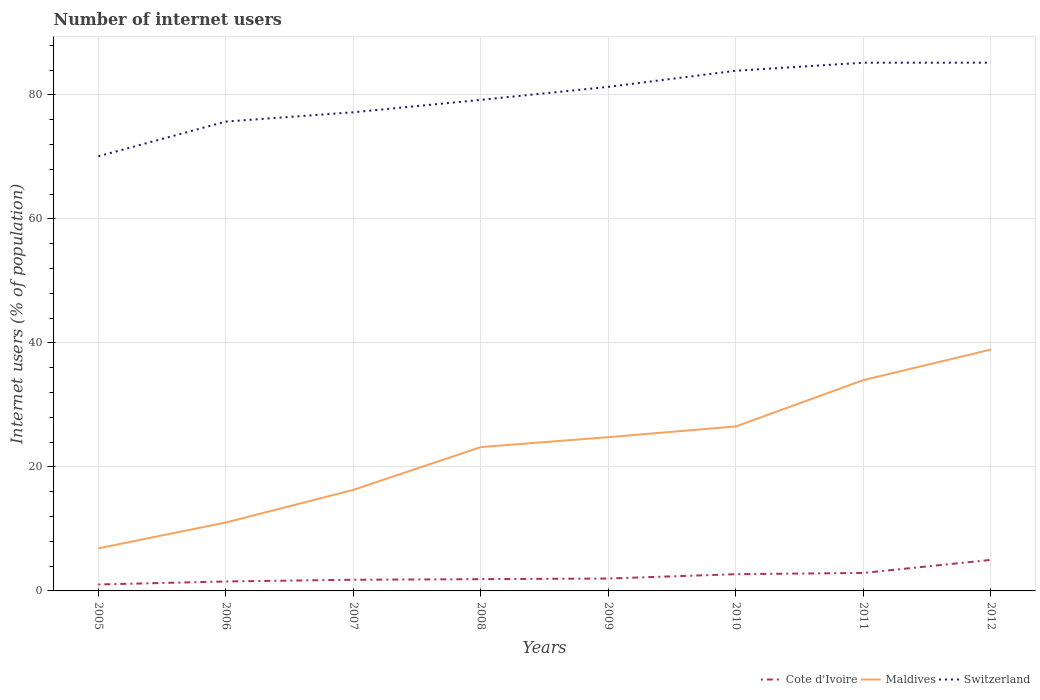Does the line corresponding to Cote d'Ivoire intersect with the line corresponding to Maldives?
Give a very brief answer. No. Across all years, what is the maximum number of internet users in Cote d'Ivoire?
Ensure brevity in your answer.  1.04. What is the total number of internet users in Cote d'Ivoire in the graph?
Your answer should be compact. -1.1. What is the difference between the highest and the second highest number of internet users in Maldives?
Make the answer very short. 32.06. What is the difference between the highest and the lowest number of internet users in Cote d'Ivoire?
Provide a short and direct response. 3. How many years are there in the graph?
Make the answer very short. 8. Where does the legend appear in the graph?
Give a very brief answer. Bottom right. How many legend labels are there?
Make the answer very short. 3. What is the title of the graph?
Offer a terse response. Number of internet users. What is the label or title of the Y-axis?
Make the answer very short. Internet users (% of population). What is the Internet users (% of population) of Cote d'Ivoire in 2005?
Give a very brief answer. 1.04. What is the Internet users (% of population) in Maldives in 2005?
Your answer should be compact. 6.87. What is the Internet users (% of population) in Switzerland in 2005?
Provide a short and direct response. 70.1. What is the Internet users (% of population) of Cote d'Ivoire in 2006?
Give a very brief answer. 1.52. What is the Internet users (% of population) in Maldives in 2006?
Your response must be concise. 11.04. What is the Internet users (% of population) in Switzerland in 2006?
Make the answer very short. 75.7. What is the Internet users (% of population) in Cote d'Ivoire in 2007?
Give a very brief answer. 1.8. What is the Internet users (% of population) of Switzerland in 2007?
Offer a terse response. 77.2. What is the Internet users (% of population) of Cote d'Ivoire in 2008?
Offer a very short reply. 1.9. What is the Internet users (% of population) of Maldives in 2008?
Give a very brief answer. 23.2. What is the Internet users (% of population) in Switzerland in 2008?
Provide a succinct answer. 79.2. What is the Internet users (% of population) of Cote d'Ivoire in 2009?
Keep it short and to the point. 2. What is the Internet users (% of population) in Maldives in 2009?
Ensure brevity in your answer.  24.8. What is the Internet users (% of population) of Switzerland in 2009?
Provide a succinct answer. 81.3. What is the Internet users (% of population) in Cote d'Ivoire in 2010?
Your response must be concise. 2.7. What is the Internet users (% of population) in Maldives in 2010?
Your answer should be compact. 26.53. What is the Internet users (% of population) in Switzerland in 2010?
Your answer should be very brief. 83.9. What is the Internet users (% of population) of Cote d'Ivoire in 2011?
Make the answer very short. 2.9. What is the Internet users (% of population) in Maldives in 2011?
Provide a succinct answer. 34. What is the Internet users (% of population) in Switzerland in 2011?
Offer a terse response. 85.19. What is the Internet users (% of population) of Cote d'Ivoire in 2012?
Provide a succinct answer. 5. What is the Internet users (% of population) of Maldives in 2012?
Make the answer very short. 38.93. What is the Internet users (% of population) in Switzerland in 2012?
Make the answer very short. 85.2. Across all years, what is the maximum Internet users (% of population) of Cote d'Ivoire?
Provide a short and direct response. 5. Across all years, what is the maximum Internet users (% of population) in Maldives?
Give a very brief answer. 38.93. Across all years, what is the maximum Internet users (% of population) of Switzerland?
Your answer should be compact. 85.2. Across all years, what is the minimum Internet users (% of population) of Cote d'Ivoire?
Your response must be concise. 1.04. Across all years, what is the minimum Internet users (% of population) in Maldives?
Give a very brief answer. 6.87. Across all years, what is the minimum Internet users (% of population) of Switzerland?
Make the answer very short. 70.1. What is the total Internet users (% of population) in Cote d'Ivoire in the graph?
Provide a short and direct response. 18.86. What is the total Internet users (% of population) in Maldives in the graph?
Offer a very short reply. 181.67. What is the total Internet users (% of population) in Switzerland in the graph?
Your answer should be compact. 637.79. What is the difference between the Internet users (% of population) of Cote d'Ivoire in 2005 and that in 2006?
Provide a succinct answer. -0.49. What is the difference between the Internet users (% of population) in Maldives in 2005 and that in 2006?
Offer a very short reply. -4.17. What is the difference between the Internet users (% of population) of Switzerland in 2005 and that in 2006?
Provide a succinct answer. -5.6. What is the difference between the Internet users (% of population) in Cote d'Ivoire in 2005 and that in 2007?
Provide a succinct answer. -0.76. What is the difference between the Internet users (% of population) in Maldives in 2005 and that in 2007?
Keep it short and to the point. -9.43. What is the difference between the Internet users (% of population) of Switzerland in 2005 and that in 2007?
Provide a succinct answer. -7.1. What is the difference between the Internet users (% of population) of Cote d'Ivoire in 2005 and that in 2008?
Your answer should be compact. -0.86. What is the difference between the Internet users (% of population) of Maldives in 2005 and that in 2008?
Make the answer very short. -16.33. What is the difference between the Internet users (% of population) in Switzerland in 2005 and that in 2008?
Provide a short and direct response. -9.1. What is the difference between the Internet users (% of population) in Cote d'Ivoire in 2005 and that in 2009?
Offer a terse response. -0.96. What is the difference between the Internet users (% of population) in Maldives in 2005 and that in 2009?
Provide a succinct answer. -17.93. What is the difference between the Internet users (% of population) of Cote d'Ivoire in 2005 and that in 2010?
Offer a terse response. -1.66. What is the difference between the Internet users (% of population) of Maldives in 2005 and that in 2010?
Provide a succinct answer. -19.66. What is the difference between the Internet users (% of population) of Switzerland in 2005 and that in 2010?
Make the answer very short. -13.8. What is the difference between the Internet users (% of population) in Cote d'Ivoire in 2005 and that in 2011?
Provide a succinct answer. -1.86. What is the difference between the Internet users (% of population) in Maldives in 2005 and that in 2011?
Your answer should be very brief. -27.13. What is the difference between the Internet users (% of population) of Switzerland in 2005 and that in 2011?
Provide a succinct answer. -15.09. What is the difference between the Internet users (% of population) in Cote d'Ivoire in 2005 and that in 2012?
Provide a short and direct response. -3.96. What is the difference between the Internet users (% of population) in Maldives in 2005 and that in 2012?
Give a very brief answer. -32.06. What is the difference between the Internet users (% of population) of Switzerland in 2005 and that in 2012?
Your answer should be very brief. -15.1. What is the difference between the Internet users (% of population) in Cote d'Ivoire in 2006 and that in 2007?
Ensure brevity in your answer.  -0.28. What is the difference between the Internet users (% of population) of Maldives in 2006 and that in 2007?
Your answer should be very brief. -5.26. What is the difference between the Internet users (% of population) in Cote d'Ivoire in 2006 and that in 2008?
Offer a very short reply. -0.38. What is the difference between the Internet users (% of population) in Maldives in 2006 and that in 2008?
Your answer should be compact. -12.16. What is the difference between the Internet users (% of population) in Switzerland in 2006 and that in 2008?
Make the answer very short. -3.5. What is the difference between the Internet users (% of population) of Cote d'Ivoire in 2006 and that in 2009?
Your response must be concise. -0.48. What is the difference between the Internet users (% of population) of Maldives in 2006 and that in 2009?
Keep it short and to the point. -13.76. What is the difference between the Internet users (% of population) of Cote d'Ivoire in 2006 and that in 2010?
Make the answer very short. -1.18. What is the difference between the Internet users (% of population) in Maldives in 2006 and that in 2010?
Offer a terse response. -15.49. What is the difference between the Internet users (% of population) in Cote d'Ivoire in 2006 and that in 2011?
Keep it short and to the point. -1.38. What is the difference between the Internet users (% of population) of Maldives in 2006 and that in 2011?
Offer a very short reply. -22.96. What is the difference between the Internet users (% of population) in Switzerland in 2006 and that in 2011?
Keep it short and to the point. -9.49. What is the difference between the Internet users (% of population) in Cote d'Ivoire in 2006 and that in 2012?
Offer a terse response. -3.48. What is the difference between the Internet users (% of population) of Maldives in 2006 and that in 2012?
Provide a succinct answer. -27.89. What is the difference between the Internet users (% of population) in Cote d'Ivoire in 2007 and that in 2008?
Your response must be concise. -0.1. What is the difference between the Internet users (% of population) in Maldives in 2007 and that in 2008?
Offer a terse response. -6.9. What is the difference between the Internet users (% of population) of Switzerland in 2007 and that in 2008?
Offer a terse response. -2. What is the difference between the Internet users (% of population) of Cote d'Ivoire in 2007 and that in 2009?
Ensure brevity in your answer.  -0.2. What is the difference between the Internet users (% of population) of Maldives in 2007 and that in 2009?
Offer a terse response. -8.5. What is the difference between the Internet users (% of population) of Maldives in 2007 and that in 2010?
Offer a terse response. -10.23. What is the difference between the Internet users (% of population) of Switzerland in 2007 and that in 2010?
Keep it short and to the point. -6.7. What is the difference between the Internet users (% of population) in Maldives in 2007 and that in 2011?
Provide a short and direct response. -17.7. What is the difference between the Internet users (% of population) in Switzerland in 2007 and that in 2011?
Make the answer very short. -7.99. What is the difference between the Internet users (% of population) of Maldives in 2007 and that in 2012?
Your answer should be very brief. -22.63. What is the difference between the Internet users (% of population) of Switzerland in 2008 and that in 2009?
Make the answer very short. -2.1. What is the difference between the Internet users (% of population) of Maldives in 2008 and that in 2010?
Provide a succinct answer. -3.33. What is the difference between the Internet users (% of population) of Cote d'Ivoire in 2008 and that in 2011?
Provide a succinct answer. -1. What is the difference between the Internet users (% of population) in Maldives in 2008 and that in 2011?
Provide a succinct answer. -10.8. What is the difference between the Internet users (% of population) of Switzerland in 2008 and that in 2011?
Give a very brief answer. -5.99. What is the difference between the Internet users (% of population) in Cote d'Ivoire in 2008 and that in 2012?
Your response must be concise. -3.1. What is the difference between the Internet users (% of population) in Maldives in 2008 and that in 2012?
Provide a short and direct response. -15.73. What is the difference between the Internet users (% of population) in Maldives in 2009 and that in 2010?
Give a very brief answer. -1.73. What is the difference between the Internet users (% of population) of Cote d'Ivoire in 2009 and that in 2011?
Offer a terse response. -0.9. What is the difference between the Internet users (% of population) of Maldives in 2009 and that in 2011?
Offer a very short reply. -9.2. What is the difference between the Internet users (% of population) of Switzerland in 2009 and that in 2011?
Your answer should be compact. -3.89. What is the difference between the Internet users (% of population) in Cote d'Ivoire in 2009 and that in 2012?
Offer a terse response. -3. What is the difference between the Internet users (% of population) in Maldives in 2009 and that in 2012?
Ensure brevity in your answer.  -14.13. What is the difference between the Internet users (% of population) of Cote d'Ivoire in 2010 and that in 2011?
Keep it short and to the point. -0.2. What is the difference between the Internet users (% of population) in Maldives in 2010 and that in 2011?
Your response must be concise. -7.47. What is the difference between the Internet users (% of population) of Switzerland in 2010 and that in 2011?
Offer a terse response. -1.29. What is the difference between the Internet users (% of population) of Cote d'Ivoire in 2010 and that in 2012?
Provide a succinct answer. -2.3. What is the difference between the Internet users (% of population) of Maldives in 2010 and that in 2012?
Keep it short and to the point. -12.4. What is the difference between the Internet users (% of population) in Switzerland in 2010 and that in 2012?
Offer a terse response. -1.3. What is the difference between the Internet users (% of population) in Maldives in 2011 and that in 2012?
Make the answer very short. -4.93. What is the difference between the Internet users (% of population) of Switzerland in 2011 and that in 2012?
Make the answer very short. -0.01. What is the difference between the Internet users (% of population) of Cote d'Ivoire in 2005 and the Internet users (% of population) of Maldives in 2006?
Keep it short and to the point. -10. What is the difference between the Internet users (% of population) of Cote d'Ivoire in 2005 and the Internet users (% of population) of Switzerland in 2006?
Offer a very short reply. -74.66. What is the difference between the Internet users (% of population) of Maldives in 2005 and the Internet users (% of population) of Switzerland in 2006?
Your answer should be compact. -68.83. What is the difference between the Internet users (% of population) in Cote d'Ivoire in 2005 and the Internet users (% of population) in Maldives in 2007?
Offer a very short reply. -15.26. What is the difference between the Internet users (% of population) in Cote d'Ivoire in 2005 and the Internet users (% of population) in Switzerland in 2007?
Your answer should be compact. -76.16. What is the difference between the Internet users (% of population) in Maldives in 2005 and the Internet users (% of population) in Switzerland in 2007?
Your response must be concise. -70.33. What is the difference between the Internet users (% of population) in Cote d'Ivoire in 2005 and the Internet users (% of population) in Maldives in 2008?
Offer a terse response. -22.16. What is the difference between the Internet users (% of population) in Cote d'Ivoire in 2005 and the Internet users (% of population) in Switzerland in 2008?
Your answer should be compact. -78.16. What is the difference between the Internet users (% of population) in Maldives in 2005 and the Internet users (% of population) in Switzerland in 2008?
Offer a very short reply. -72.33. What is the difference between the Internet users (% of population) of Cote d'Ivoire in 2005 and the Internet users (% of population) of Maldives in 2009?
Give a very brief answer. -23.76. What is the difference between the Internet users (% of population) in Cote d'Ivoire in 2005 and the Internet users (% of population) in Switzerland in 2009?
Offer a terse response. -80.26. What is the difference between the Internet users (% of population) of Maldives in 2005 and the Internet users (% of population) of Switzerland in 2009?
Provide a succinct answer. -74.43. What is the difference between the Internet users (% of population) of Cote d'Ivoire in 2005 and the Internet users (% of population) of Maldives in 2010?
Make the answer very short. -25.49. What is the difference between the Internet users (% of population) of Cote d'Ivoire in 2005 and the Internet users (% of population) of Switzerland in 2010?
Your response must be concise. -82.86. What is the difference between the Internet users (% of population) of Maldives in 2005 and the Internet users (% of population) of Switzerland in 2010?
Make the answer very short. -77.03. What is the difference between the Internet users (% of population) of Cote d'Ivoire in 2005 and the Internet users (% of population) of Maldives in 2011?
Your response must be concise. -32.96. What is the difference between the Internet users (% of population) of Cote d'Ivoire in 2005 and the Internet users (% of population) of Switzerland in 2011?
Offer a terse response. -84.15. What is the difference between the Internet users (% of population) in Maldives in 2005 and the Internet users (% of population) in Switzerland in 2011?
Provide a short and direct response. -78.32. What is the difference between the Internet users (% of population) in Cote d'Ivoire in 2005 and the Internet users (% of population) in Maldives in 2012?
Give a very brief answer. -37.89. What is the difference between the Internet users (% of population) in Cote d'Ivoire in 2005 and the Internet users (% of population) in Switzerland in 2012?
Keep it short and to the point. -84.16. What is the difference between the Internet users (% of population) in Maldives in 2005 and the Internet users (% of population) in Switzerland in 2012?
Make the answer very short. -78.33. What is the difference between the Internet users (% of population) in Cote d'Ivoire in 2006 and the Internet users (% of population) in Maldives in 2007?
Provide a succinct answer. -14.78. What is the difference between the Internet users (% of population) in Cote d'Ivoire in 2006 and the Internet users (% of population) in Switzerland in 2007?
Your answer should be very brief. -75.68. What is the difference between the Internet users (% of population) in Maldives in 2006 and the Internet users (% of population) in Switzerland in 2007?
Provide a succinct answer. -66.16. What is the difference between the Internet users (% of population) of Cote d'Ivoire in 2006 and the Internet users (% of population) of Maldives in 2008?
Give a very brief answer. -21.68. What is the difference between the Internet users (% of population) of Cote d'Ivoire in 2006 and the Internet users (% of population) of Switzerland in 2008?
Keep it short and to the point. -77.68. What is the difference between the Internet users (% of population) of Maldives in 2006 and the Internet users (% of population) of Switzerland in 2008?
Ensure brevity in your answer.  -68.16. What is the difference between the Internet users (% of population) of Cote d'Ivoire in 2006 and the Internet users (% of population) of Maldives in 2009?
Offer a very short reply. -23.28. What is the difference between the Internet users (% of population) of Cote d'Ivoire in 2006 and the Internet users (% of population) of Switzerland in 2009?
Offer a terse response. -79.78. What is the difference between the Internet users (% of population) of Maldives in 2006 and the Internet users (% of population) of Switzerland in 2009?
Your answer should be very brief. -70.26. What is the difference between the Internet users (% of population) in Cote d'Ivoire in 2006 and the Internet users (% of population) in Maldives in 2010?
Ensure brevity in your answer.  -25.01. What is the difference between the Internet users (% of population) of Cote d'Ivoire in 2006 and the Internet users (% of population) of Switzerland in 2010?
Keep it short and to the point. -82.38. What is the difference between the Internet users (% of population) in Maldives in 2006 and the Internet users (% of population) in Switzerland in 2010?
Your response must be concise. -72.86. What is the difference between the Internet users (% of population) in Cote d'Ivoire in 2006 and the Internet users (% of population) in Maldives in 2011?
Provide a succinct answer. -32.48. What is the difference between the Internet users (% of population) in Cote d'Ivoire in 2006 and the Internet users (% of population) in Switzerland in 2011?
Your response must be concise. -83.67. What is the difference between the Internet users (% of population) of Maldives in 2006 and the Internet users (% of population) of Switzerland in 2011?
Your answer should be compact. -74.16. What is the difference between the Internet users (% of population) of Cote d'Ivoire in 2006 and the Internet users (% of population) of Maldives in 2012?
Your answer should be very brief. -37.41. What is the difference between the Internet users (% of population) of Cote d'Ivoire in 2006 and the Internet users (% of population) of Switzerland in 2012?
Your response must be concise. -83.68. What is the difference between the Internet users (% of population) of Maldives in 2006 and the Internet users (% of population) of Switzerland in 2012?
Offer a very short reply. -74.16. What is the difference between the Internet users (% of population) in Cote d'Ivoire in 2007 and the Internet users (% of population) in Maldives in 2008?
Keep it short and to the point. -21.4. What is the difference between the Internet users (% of population) of Cote d'Ivoire in 2007 and the Internet users (% of population) of Switzerland in 2008?
Provide a short and direct response. -77.4. What is the difference between the Internet users (% of population) of Maldives in 2007 and the Internet users (% of population) of Switzerland in 2008?
Offer a very short reply. -62.9. What is the difference between the Internet users (% of population) in Cote d'Ivoire in 2007 and the Internet users (% of population) in Switzerland in 2009?
Provide a succinct answer. -79.5. What is the difference between the Internet users (% of population) of Maldives in 2007 and the Internet users (% of population) of Switzerland in 2009?
Offer a terse response. -65. What is the difference between the Internet users (% of population) in Cote d'Ivoire in 2007 and the Internet users (% of population) in Maldives in 2010?
Offer a terse response. -24.73. What is the difference between the Internet users (% of population) in Cote d'Ivoire in 2007 and the Internet users (% of population) in Switzerland in 2010?
Your answer should be very brief. -82.1. What is the difference between the Internet users (% of population) in Maldives in 2007 and the Internet users (% of population) in Switzerland in 2010?
Offer a terse response. -67.6. What is the difference between the Internet users (% of population) of Cote d'Ivoire in 2007 and the Internet users (% of population) of Maldives in 2011?
Keep it short and to the point. -32.2. What is the difference between the Internet users (% of population) of Cote d'Ivoire in 2007 and the Internet users (% of population) of Switzerland in 2011?
Provide a short and direct response. -83.39. What is the difference between the Internet users (% of population) in Maldives in 2007 and the Internet users (% of population) in Switzerland in 2011?
Your response must be concise. -68.89. What is the difference between the Internet users (% of population) in Cote d'Ivoire in 2007 and the Internet users (% of population) in Maldives in 2012?
Keep it short and to the point. -37.13. What is the difference between the Internet users (% of population) of Cote d'Ivoire in 2007 and the Internet users (% of population) of Switzerland in 2012?
Offer a terse response. -83.4. What is the difference between the Internet users (% of population) in Maldives in 2007 and the Internet users (% of population) in Switzerland in 2012?
Your answer should be compact. -68.9. What is the difference between the Internet users (% of population) of Cote d'Ivoire in 2008 and the Internet users (% of population) of Maldives in 2009?
Ensure brevity in your answer.  -22.9. What is the difference between the Internet users (% of population) of Cote d'Ivoire in 2008 and the Internet users (% of population) of Switzerland in 2009?
Your answer should be very brief. -79.4. What is the difference between the Internet users (% of population) of Maldives in 2008 and the Internet users (% of population) of Switzerland in 2009?
Provide a succinct answer. -58.1. What is the difference between the Internet users (% of population) of Cote d'Ivoire in 2008 and the Internet users (% of population) of Maldives in 2010?
Your answer should be compact. -24.63. What is the difference between the Internet users (% of population) of Cote d'Ivoire in 2008 and the Internet users (% of population) of Switzerland in 2010?
Make the answer very short. -82. What is the difference between the Internet users (% of population) of Maldives in 2008 and the Internet users (% of population) of Switzerland in 2010?
Offer a terse response. -60.7. What is the difference between the Internet users (% of population) of Cote d'Ivoire in 2008 and the Internet users (% of population) of Maldives in 2011?
Your response must be concise. -32.1. What is the difference between the Internet users (% of population) in Cote d'Ivoire in 2008 and the Internet users (% of population) in Switzerland in 2011?
Offer a very short reply. -83.29. What is the difference between the Internet users (% of population) in Maldives in 2008 and the Internet users (% of population) in Switzerland in 2011?
Make the answer very short. -61.99. What is the difference between the Internet users (% of population) of Cote d'Ivoire in 2008 and the Internet users (% of population) of Maldives in 2012?
Offer a terse response. -37.03. What is the difference between the Internet users (% of population) in Cote d'Ivoire in 2008 and the Internet users (% of population) in Switzerland in 2012?
Make the answer very short. -83.3. What is the difference between the Internet users (% of population) of Maldives in 2008 and the Internet users (% of population) of Switzerland in 2012?
Your answer should be compact. -62. What is the difference between the Internet users (% of population) in Cote d'Ivoire in 2009 and the Internet users (% of population) in Maldives in 2010?
Your answer should be compact. -24.53. What is the difference between the Internet users (% of population) of Cote d'Ivoire in 2009 and the Internet users (% of population) of Switzerland in 2010?
Give a very brief answer. -81.9. What is the difference between the Internet users (% of population) in Maldives in 2009 and the Internet users (% of population) in Switzerland in 2010?
Make the answer very short. -59.1. What is the difference between the Internet users (% of population) in Cote d'Ivoire in 2009 and the Internet users (% of population) in Maldives in 2011?
Keep it short and to the point. -32. What is the difference between the Internet users (% of population) in Cote d'Ivoire in 2009 and the Internet users (% of population) in Switzerland in 2011?
Give a very brief answer. -83.19. What is the difference between the Internet users (% of population) of Maldives in 2009 and the Internet users (% of population) of Switzerland in 2011?
Ensure brevity in your answer.  -60.39. What is the difference between the Internet users (% of population) in Cote d'Ivoire in 2009 and the Internet users (% of population) in Maldives in 2012?
Your answer should be compact. -36.93. What is the difference between the Internet users (% of population) in Cote d'Ivoire in 2009 and the Internet users (% of population) in Switzerland in 2012?
Provide a short and direct response. -83.2. What is the difference between the Internet users (% of population) of Maldives in 2009 and the Internet users (% of population) of Switzerland in 2012?
Ensure brevity in your answer.  -60.4. What is the difference between the Internet users (% of population) in Cote d'Ivoire in 2010 and the Internet users (% of population) in Maldives in 2011?
Make the answer very short. -31.3. What is the difference between the Internet users (% of population) of Cote d'Ivoire in 2010 and the Internet users (% of population) of Switzerland in 2011?
Provide a succinct answer. -82.49. What is the difference between the Internet users (% of population) in Maldives in 2010 and the Internet users (% of population) in Switzerland in 2011?
Your response must be concise. -58.66. What is the difference between the Internet users (% of population) of Cote d'Ivoire in 2010 and the Internet users (% of population) of Maldives in 2012?
Offer a very short reply. -36.23. What is the difference between the Internet users (% of population) in Cote d'Ivoire in 2010 and the Internet users (% of population) in Switzerland in 2012?
Offer a very short reply. -82.5. What is the difference between the Internet users (% of population) of Maldives in 2010 and the Internet users (% of population) of Switzerland in 2012?
Your answer should be very brief. -58.67. What is the difference between the Internet users (% of population) in Cote d'Ivoire in 2011 and the Internet users (% of population) in Maldives in 2012?
Provide a short and direct response. -36.03. What is the difference between the Internet users (% of population) in Cote d'Ivoire in 2011 and the Internet users (% of population) in Switzerland in 2012?
Keep it short and to the point. -82.3. What is the difference between the Internet users (% of population) of Maldives in 2011 and the Internet users (% of population) of Switzerland in 2012?
Your answer should be very brief. -51.2. What is the average Internet users (% of population) in Cote d'Ivoire per year?
Give a very brief answer. 2.36. What is the average Internet users (% of population) in Maldives per year?
Make the answer very short. 22.71. What is the average Internet users (% of population) in Switzerland per year?
Give a very brief answer. 79.72. In the year 2005, what is the difference between the Internet users (% of population) in Cote d'Ivoire and Internet users (% of population) in Maldives?
Your response must be concise. -5.83. In the year 2005, what is the difference between the Internet users (% of population) of Cote d'Ivoire and Internet users (% of population) of Switzerland?
Ensure brevity in your answer.  -69.06. In the year 2005, what is the difference between the Internet users (% of population) in Maldives and Internet users (% of population) in Switzerland?
Offer a terse response. -63.23. In the year 2006, what is the difference between the Internet users (% of population) in Cote d'Ivoire and Internet users (% of population) in Maldives?
Offer a very short reply. -9.51. In the year 2006, what is the difference between the Internet users (% of population) in Cote d'Ivoire and Internet users (% of population) in Switzerland?
Offer a terse response. -74.18. In the year 2006, what is the difference between the Internet users (% of population) in Maldives and Internet users (% of population) in Switzerland?
Your answer should be very brief. -64.66. In the year 2007, what is the difference between the Internet users (% of population) of Cote d'Ivoire and Internet users (% of population) of Maldives?
Provide a succinct answer. -14.5. In the year 2007, what is the difference between the Internet users (% of population) of Cote d'Ivoire and Internet users (% of population) of Switzerland?
Offer a very short reply. -75.4. In the year 2007, what is the difference between the Internet users (% of population) in Maldives and Internet users (% of population) in Switzerland?
Your answer should be compact. -60.9. In the year 2008, what is the difference between the Internet users (% of population) of Cote d'Ivoire and Internet users (% of population) of Maldives?
Ensure brevity in your answer.  -21.3. In the year 2008, what is the difference between the Internet users (% of population) of Cote d'Ivoire and Internet users (% of population) of Switzerland?
Your answer should be compact. -77.3. In the year 2008, what is the difference between the Internet users (% of population) in Maldives and Internet users (% of population) in Switzerland?
Provide a short and direct response. -56. In the year 2009, what is the difference between the Internet users (% of population) in Cote d'Ivoire and Internet users (% of population) in Maldives?
Give a very brief answer. -22.8. In the year 2009, what is the difference between the Internet users (% of population) of Cote d'Ivoire and Internet users (% of population) of Switzerland?
Your answer should be compact. -79.3. In the year 2009, what is the difference between the Internet users (% of population) in Maldives and Internet users (% of population) in Switzerland?
Offer a terse response. -56.5. In the year 2010, what is the difference between the Internet users (% of population) in Cote d'Ivoire and Internet users (% of population) in Maldives?
Your response must be concise. -23.83. In the year 2010, what is the difference between the Internet users (% of population) of Cote d'Ivoire and Internet users (% of population) of Switzerland?
Offer a very short reply. -81.2. In the year 2010, what is the difference between the Internet users (% of population) of Maldives and Internet users (% of population) of Switzerland?
Offer a terse response. -57.37. In the year 2011, what is the difference between the Internet users (% of population) of Cote d'Ivoire and Internet users (% of population) of Maldives?
Offer a terse response. -31.1. In the year 2011, what is the difference between the Internet users (% of population) in Cote d'Ivoire and Internet users (% of population) in Switzerland?
Give a very brief answer. -82.29. In the year 2011, what is the difference between the Internet users (% of population) in Maldives and Internet users (% of population) in Switzerland?
Your answer should be very brief. -51.19. In the year 2012, what is the difference between the Internet users (% of population) of Cote d'Ivoire and Internet users (% of population) of Maldives?
Your response must be concise. -33.93. In the year 2012, what is the difference between the Internet users (% of population) of Cote d'Ivoire and Internet users (% of population) of Switzerland?
Provide a short and direct response. -80.2. In the year 2012, what is the difference between the Internet users (% of population) of Maldives and Internet users (% of population) of Switzerland?
Your response must be concise. -46.27. What is the ratio of the Internet users (% of population) of Cote d'Ivoire in 2005 to that in 2006?
Your response must be concise. 0.68. What is the ratio of the Internet users (% of population) of Maldives in 2005 to that in 2006?
Provide a succinct answer. 0.62. What is the ratio of the Internet users (% of population) of Switzerland in 2005 to that in 2006?
Make the answer very short. 0.93. What is the ratio of the Internet users (% of population) of Cote d'Ivoire in 2005 to that in 2007?
Provide a short and direct response. 0.58. What is the ratio of the Internet users (% of population) of Maldives in 2005 to that in 2007?
Your response must be concise. 0.42. What is the ratio of the Internet users (% of population) of Switzerland in 2005 to that in 2007?
Make the answer very short. 0.91. What is the ratio of the Internet users (% of population) of Cote d'Ivoire in 2005 to that in 2008?
Ensure brevity in your answer.  0.55. What is the ratio of the Internet users (% of population) of Maldives in 2005 to that in 2008?
Your response must be concise. 0.3. What is the ratio of the Internet users (% of population) of Switzerland in 2005 to that in 2008?
Your answer should be very brief. 0.89. What is the ratio of the Internet users (% of population) in Cote d'Ivoire in 2005 to that in 2009?
Offer a very short reply. 0.52. What is the ratio of the Internet users (% of population) in Maldives in 2005 to that in 2009?
Make the answer very short. 0.28. What is the ratio of the Internet users (% of population) of Switzerland in 2005 to that in 2009?
Your answer should be very brief. 0.86. What is the ratio of the Internet users (% of population) of Cote d'Ivoire in 2005 to that in 2010?
Your response must be concise. 0.38. What is the ratio of the Internet users (% of population) of Maldives in 2005 to that in 2010?
Your answer should be compact. 0.26. What is the ratio of the Internet users (% of population) in Switzerland in 2005 to that in 2010?
Offer a terse response. 0.84. What is the ratio of the Internet users (% of population) in Cote d'Ivoire in 2005 to that in 2011?
Your answer should be compact. 0.36. What is the ratio of the Internet users (% of population) in Maldives in 2005 to that in 2011?
Keep it short and to the point. 0.2. What is the ratio of the Internet users (% of population) of Switzerland in 2005 to that in 2011?
Your response must be concise. 0.82. What is the ratio of the Internet users (% of population) in Cote d'Ivoire in 2005 to that in 2012?
Provide a short and direct response. 0.21. What is the ratio of the Internet users (% of population) of Maldives in 2005 to that in 2012?
Your answer should be compact. 0.18. What is the ratio of the Internet users (% of population) of Switzerland in 2005 to that in 2012?
Your response must be concise. 0.82. What is the ratio of the Internet users (% of population) in Cote d'Ivoire in 2006 to that in 2007?
Make the answer very short. 0.85. What is the ratio of the Internet users (% of population) in Maldives in 2006 to that in 2007?
Provide a succinct answer. 0.68. What is the ratio of the Internet users (% of population) in Switzerland in 2006 to that in 2007?
Your answer should be very brief. 0.98. What is the ratio of the Internet users (% of population) in Cote d'Ivoire in 2006 to that in 2008?
Offer a very short reply. 0.8. What is the ratio of the Internet users (% of population) of Maldives in 2006 to that in 2008?
Ensure brevity in your answer.  0.48. What is the ratio of the Internet users (% of population) of Switzerland in 2006 to that in 2008?
Provide a succinct answer. 0.96. What is the ratio of the Internet users (% of population) in Cote d'Ivoire in 2006 to that in 2009?
Your answer should be compact. 0.76. What is the ratio of the Internet users (% of population) in Maldives in 2006 to that in 2009?
Offer a very short reply. 0.45. What is the ratio of the Internet users (% of population) in Switzerland in 2006 to that in 2009?
Ensure brevity in your answer.  0.93. What is the ratio of the Internet users (% of population) in Cote d'Ivoire in 2006 to that in 2010?
Your response must be concise. 0.56. What is the ratio of the Internet users (% of population) of Maldives in 2006 to that in 2010?
Your answer should be compact. 0.42. What is the ratio of the Internet users (% of population) in Switzerland in 2006 to that in 2010?
Give a very brief answer. 0.9. What is the ratio of the Internet users (% of population) of Cote d'Ivoire in 2006 to that in 2011?
Your answer should be very brief. 0.53. What is the ratio of the Internet users (% of population) in Maldives in 2006 to that in 2011?
Your response must be concise. 0.32. What is the ratio of the Internet users (% of population) of Switzerland in 2006 to that in 2011?
Give a very brief answer. 0.89. What is the ratio of the Internet users (% of population) of Cote d'Ivoire in 2006 to that in 2012?
Give a very brief answer. 0.3. What is the ratio of the Internet users (% of population) of Maldives in 2006 to that in 2012?
Offer a terse response. 0.28. What is the ratio of the Internet users (% of population) of Switzerland in 2006 to that in 2012?
Keep it short and to the point. 0.89. What is the ratio of the Internet users (% of population) of Cote d'Ivoire in 2007 to that in 2008?
Offer a very short reply. 0.95. What is the ratio of the Internet users (% of population) in Maldives in 2007 to that in 2008?
Give a very brief answer. 0.7. What is the ratio of the Internet users (% of population) in Switzerland in 2007 to that in 2008?
Provide a short and direct response. 0.97. What is the ratio of the Internet users (% of population) of Maldives in 2007 to that in 2009?
Your answer should be very brief. 0.66. What is the ratio of the Internet users (% of population) in Switzerland in 2007 to that in 2009?
Your response must be concise. 0.95. What is the ratio of the Internet users (% of population) of Cote d'Ivoire in 2007 to that in 2010?
Offer a terse response. 0.67. What is the ratio of the Internet users (% of population) of Maldives in 2007 to that in 2010?
Your response must be concise. 0.61. What is the ratio of the Internet users (% of population) in Switzerland in 2007 to that in 2010?
Your response must be concise. 0.92. What is the ratio of the Internet users (% of population) of Cote d'Ivoire in 2007 to that in 2011?
Give a very brief answer. 0.62. What is the ratio of the Internet users (% of population) in Maldives in 2007 to that in 2011?
Offer a very short reply. 0.48. What is the ratio of the Internet users (% of population) in Switzerland in 2007 to that in 2011?
Offer a very short reply. 0.91. What is the ratio of the Internet users (% of population) in Cote d'Ivoire in 2007 to that in 2012?
Provide a succinct answer. 0.36. What is the ratio of the Internet users (% of population) in Maldives in 2007 to that in 2012?
Provide a succinct answer. 0.42. What is the ratio of the Internet users (% of population) in Switzerland in 2007 to that in 2012?
Offer a very short reply. 0.91. What is the ratio of the Internet users (% of population) in Cote d'Ivoire in 2008 to that in 2009?
Offer a terse response. 0.95. What is the ratio of the Internet users (% of population) in Maldives in 2008 to that in 2009?
Your response must be concise. 0.94. What is the ratio of the Internet users (% of population) in Switzerland in 2008 to that in 2009?
Your answer should be very brief. 0.97. What is the ratio of the Internet users (% of population) in Cote d'Ivoire in 2008 to that in 2010?
Your answer should be very brief. 0.7. What is the ratio of the Internet users (% of population) of Maldives in 2008 to that in 2010?
Give a very brief answer. 0.87. What is the ratio of the Internet users (% of population) of Switzerland in 2008 to that in 2010?
Offer a very short reply. 0.94. What is the ratio of the Internet users (% of population) in Cote d'Ivoire in 2008 to that in 2011?
Your answer should be compact. 0.66. What is the ratio of the Internet users (% of population) of Maldives in 2008 to that in 2011?
Your answer should be compact. 0.68. What is the ratio of the Internet users (% of population) of Switzerland in 2008 to that in 2011?
Give a very brief answer. 0.93. What is the ratio of the Internet users (% of population) of Cote d'Ivoire in 2008 to that in 2012?
Offer a very short reply. 0.38. What is the ratio of the Internet users (% of population) of Maldives in 2008 to that in 2012?
Provide a short and direct response. 0.6. What is the ratio of the Internet users (% of population) of Switzerland in 2008 to that in 2012?
Keep it short and to the point. 0.93. What is the ratio of the Internet users (% of population) in Cote d'Ivoire in 2009 to that in 2010?
Keep it short and to the point. 0.74. What is the ratio of the Internet users (% of population) in Maldives in 2009 to that in 2010?
Provide a succinct answer. 0.93. What is the ratio of the Internet users (% of population) of Cote d'Ivoire in 2009 to that in 2011?
Keep it short and to the point. 0.69. What is the ratio of the Internet users (% of population) of Maldives in 2009 to that in 2011?
Your response must be concise. 0.73. What is the ratio of the Internet users (% of population) in Switzerland in 2009 to that in 2011?
Make the answer very short. 0.95. What is the ratio of the Internet users (% of population) in Maldives in 2009 to that in 2012?
Your response must be concise. 0.64. What is the ratio of the Internet users (% of population) in Switzerland in 2009 to that in 2012?
Provide a short and direct response. 0.95. What is the ratio of the Internet users (% of population) of Cote d'Ivoire in 2010 to that in 2011?
Make the answer very short. 0.93. What is the ratio of the Internet users (% of population) of Maldives in 2010 to that in 2011?
Ensure brevity in your answer.  0.78. What is the ratio of the Internet users (% of population) in Switzerland in 2010 to that in 2011?
Make the answer very short. 0.98. What is the ratio of the Internet users (% of population) in Cote d'Ivoire in 2010 to that in 2012?
Provide a short and direct response. 0.54. What is the ratio of the Internet users (% of population) in Maldives in 2010 to that in 2012?
Offer a very short reply. 0.68. What is the ratio of the Internet users (% of population) of Switzerland in 2010 to that in 2012?
Your response must be concise. 0.98. What is the ratio of the Internet users (% of population) of Cote d'Ivoire in 2011 to that in 2012?
Keep it short and to the point. 0.58. What is the ratio of the Internet users (% of population) in Maldives in 2011 to that in 2012?
Keep it short and to the point. 0.87. What is the difference between the highest and the second highest Internet users (% of population) in Maldives?
Keep it short and to the point. 4.93. What is the difference between the highest and the second highest Internet users (% of population) in Switzerland?
Provide a succinct answer. 0.01. What is the difference between the highest and the lowest Internet users (% of population) of Cote d'Ivoire?
Your response must be concise. 3.96. What is the difference between the highest and the lowest Internet users (% of population) of Maldives?
Keep it short and to the point. 32.06. 